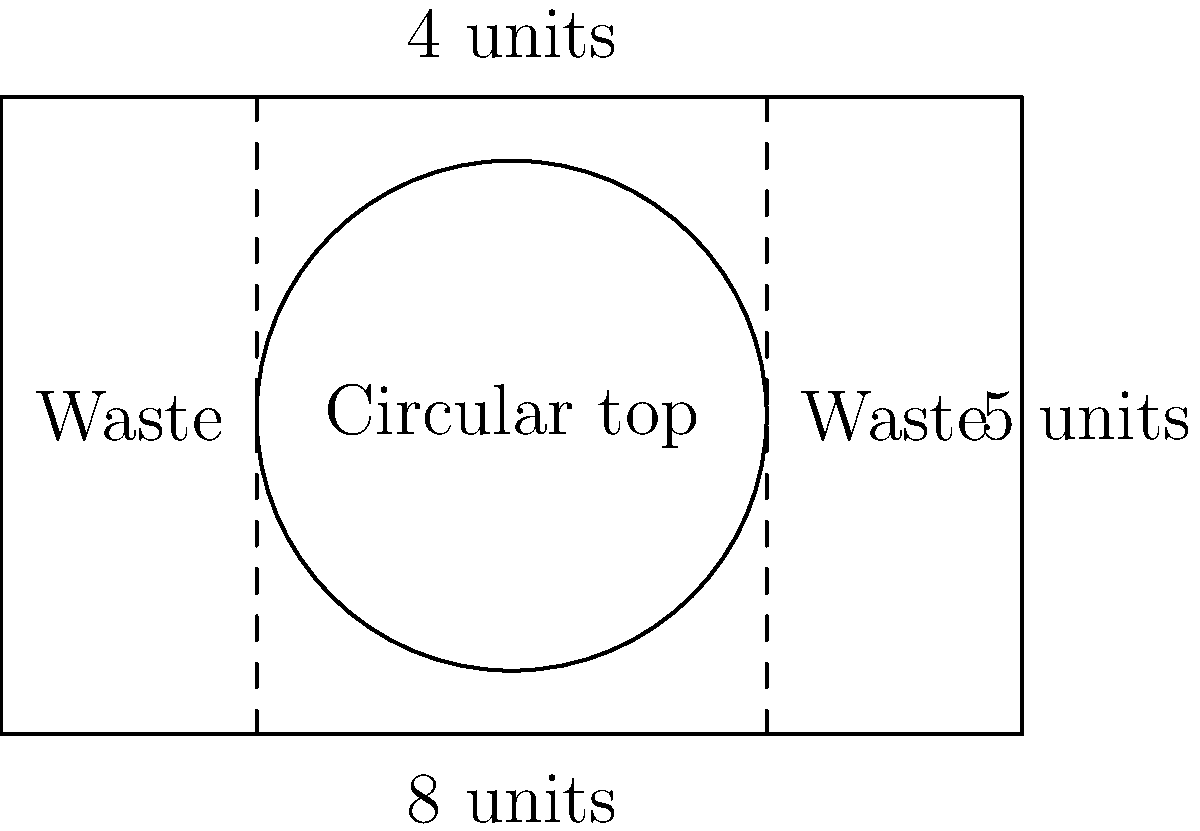As a furniture manufacturer, you need to optimize the cutting pattern for a circular table top from a rectangular wood sheet. The wood sheet measures 8 units in length and 5 units in width. The circular table top has a diameter of 4 units. What is the maximum number of circular table tops that can be cut from this single rectangular wood sheet while minimizing waste? To solve this problem, we need to follow these steps:

1. Understand the given dimensions:
   - Rectangular wood sheet: 8 units x 5 units
   - Circular table top diameter: 4 units

2. Calculate the radius of the circular table top:
   $r = \frac{diameter}{2} = \frac{4}{2} = 2$ units

3. Determine the minimum width required for each circular top:
   The minimum width is equal to the diameter, which is 4 units.

4. Calculate how many circular tops can fit along the length of the wood sheet:
   $\text{Number of tops along length} = \lfloor\frac{\text{sheet length}}{\text{top diameter}}\rfloor = \lfloor\frac{8}{4}\rfloor = 2$

5. Check if there's enough width for the circular tops:
   The sheet width (5 units) is greater than the top diameter (4 units), so there's enough width.

6. Calculate the total number of circular tops that can be cut:
   $\text{Total tops} = \text{Number of tops along length} \times 1 = 2 \times 1 = 2$

Therefore, the maximum number of circular table tops that can be cut from this single rectangular wood sheet while minimizing waste is 2.
Answer: 2 circular table tops 